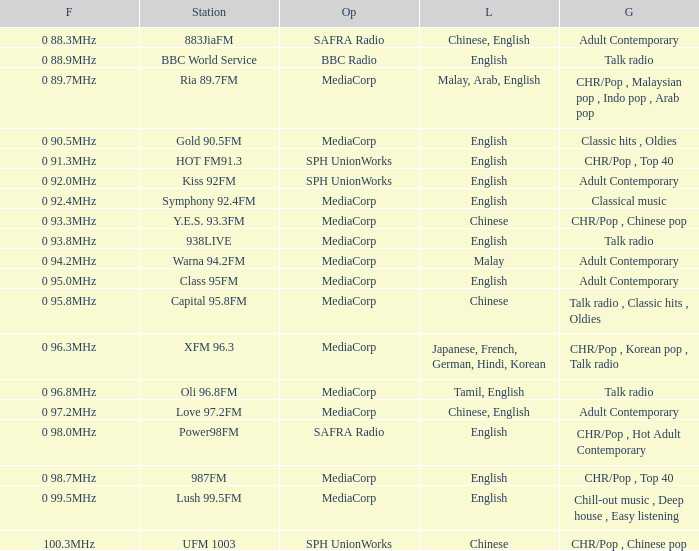Which station is operated by BBC Radio under the talk radio genre? BBC World Service. 